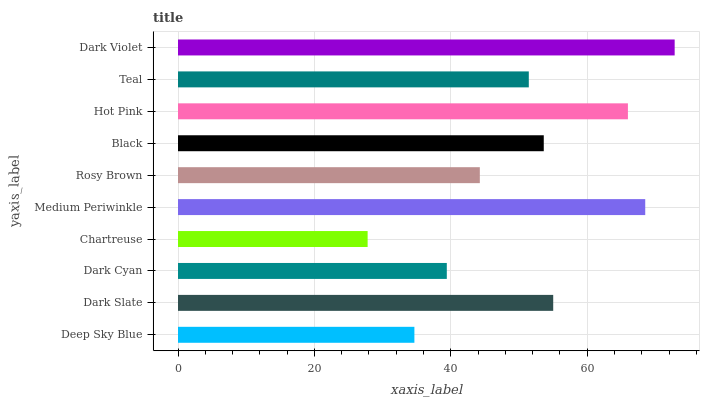Is Chartreuse the minimum?
Answer yes or no. Yes. Is Dark Violet the maximum?
Answer yes or no. Yes. Is Dark Slate the minimum?
Answer yes or no. No. Is Dark Slate the maximum?
Answer yes or no. No. Is Dark Slate greater than Deep Sky Blue?
Answer yes or no. Yes. Is Deep Sky Blue less than Dark Slate?
Answer yes or no. Yes. Is Deep Sky Blue greater than Dark Slate?
Answer yes or no. No. Is Dark Slate less than Deep Sky Blue?
Answer yes or no. No. Is Black the high median?
Answer yes or no. Yes. Is Teal the low median?
Answer yes or no. Yes. Is Medium Periwinkle the high median?
Answer yes or no. No. Is Medium Periwinkle the low median?
Answer yes or no. No. 